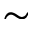Convert formula to latex. <formula><loc_0><loc_0><loc_500><loc_500>\sim</formula> 